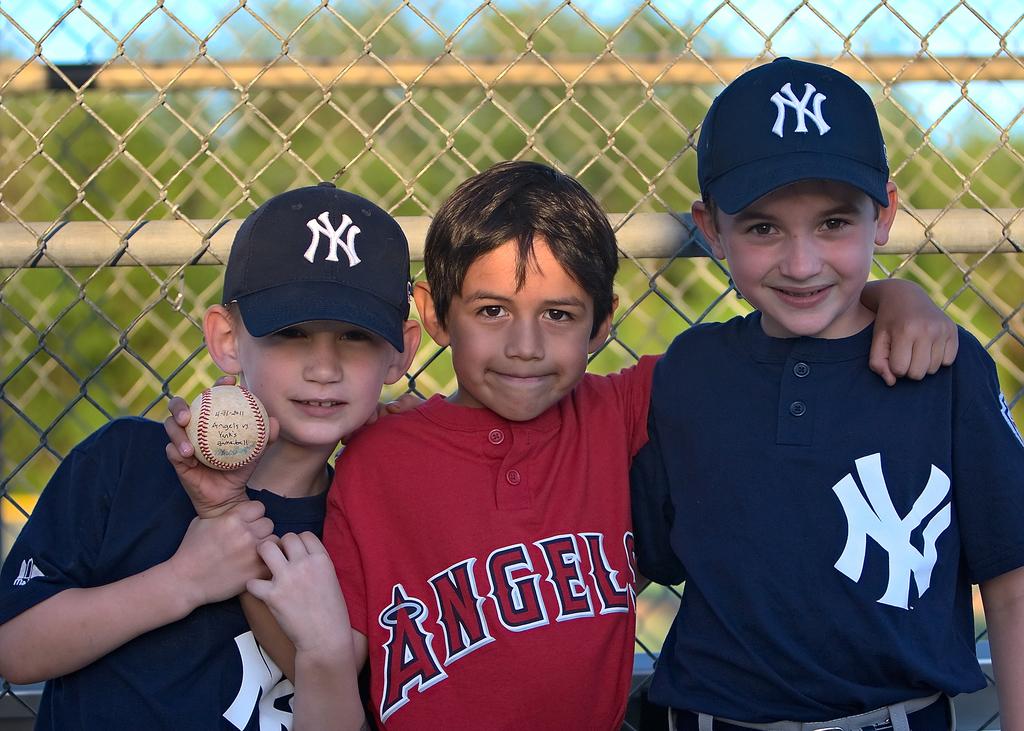What heavenly-related team name is on the red jersey?
Ensure brevity in your answer.  Angels. What letters are on the blue shirt?
Provide a short and direct response. Ny. 